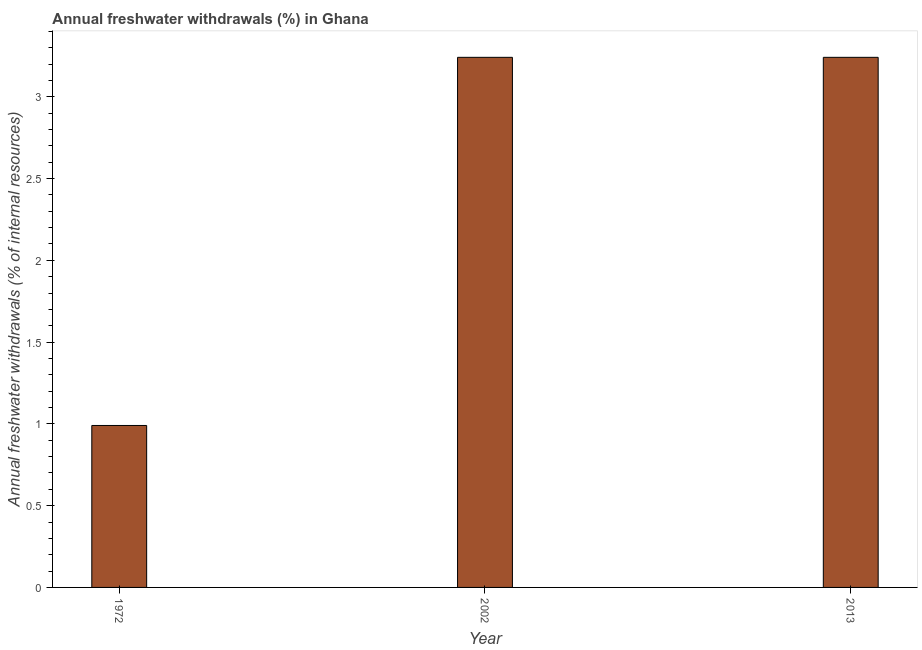Does the graph contain grids?
Make the answer very short. No. What is the title of the graph?
Provide a succinct answer. Annual freshwater withdrawals (%) in Ghana. What is the label or title of the Y-axis?
Provide a short and direct response. Annual freshwater withdrawals (% of internal resources). What is the annual freshwater withdrawals in 1972?
Provide a short and direct response. 0.99. Across all years, what is the maximum annual freshwater withdrawals?
Your answer should be compact. 3.24. Across all years, what is the minimum annual freshwater withdrawals?
Keep it short and to the point. 0.99. What is the sum of the annual freshwater withdrawals?
Offer a terse response. 7.47. What is the difference between the annual freshwater withdrawals in 1972 and 2002?
Give a very brief answer. -2.25. What is the average annual freshwater withdrawals per year?
Offer a terse response. 2.49. What is the median annual freshwater withdrawals?
Offer a very short reply. 3.24. In how many years, is the annual freshwater withdrawals greater than 2 %?
Provide a succinct answer. 2. What is the ratio of the annual freshwater withdrawals in 1972 to that in 2002?
Offer a terse response. 0.3. Is the sum of the annual freshwater withdrawals in 1972 and 2013 greater than the maximum annual freshwater withdrawals across all years?
Make the answer very short. Yes. What is the difference between the highest and the lowest annual freshwater withdrawals?
Your answer should be compact. 2.25. In how many years, is the annual freshwater withdrawals greater than the average annual freshwater withdrawals taken over all years?
Offer a terse response. 2. How many years are there in the graph?
Your response must be concise. 3. What is the difference between two consecutive major ticks on the Y-axis?
Your response must be concise. 0.5. What is the Annual freshwater withdrawals (% of internal resources) of 1972?
Your answer should be compact. 0.99. What is the Annual freshwater withdrawals (% of internal resources) of 2002?
Provide a succinct answer. 3.24. What is the Annual freshwater withdrawals (% of internal resources) of 2013?
Provide a succinct answer. 3.24. What is the difference between the Annual freshwater withdrawals (% of internal resources) in 1972 and 2002?
Your response must be concise. -2.25. What is the difference between the Annual freshwater withdrawals (% of internal resources) in 1972 and 2013?
Keep it short and to the point. -2.25. What is the difference between the Annual freshwater withdrawals (% of internal resources) in 2002 and 2013?
Provide a short and direct response. 0. What is the ratio of the Annual freshwater withdrawals (% of internal resources) in 1972 to that in 2002?
Provide a succinct answer. 0.3. What is the ratio of the Annual freshwater withdrawals (% of internal resources) in 1972 to that in 2013?
Ensure brevity in your answer.  0.3. 